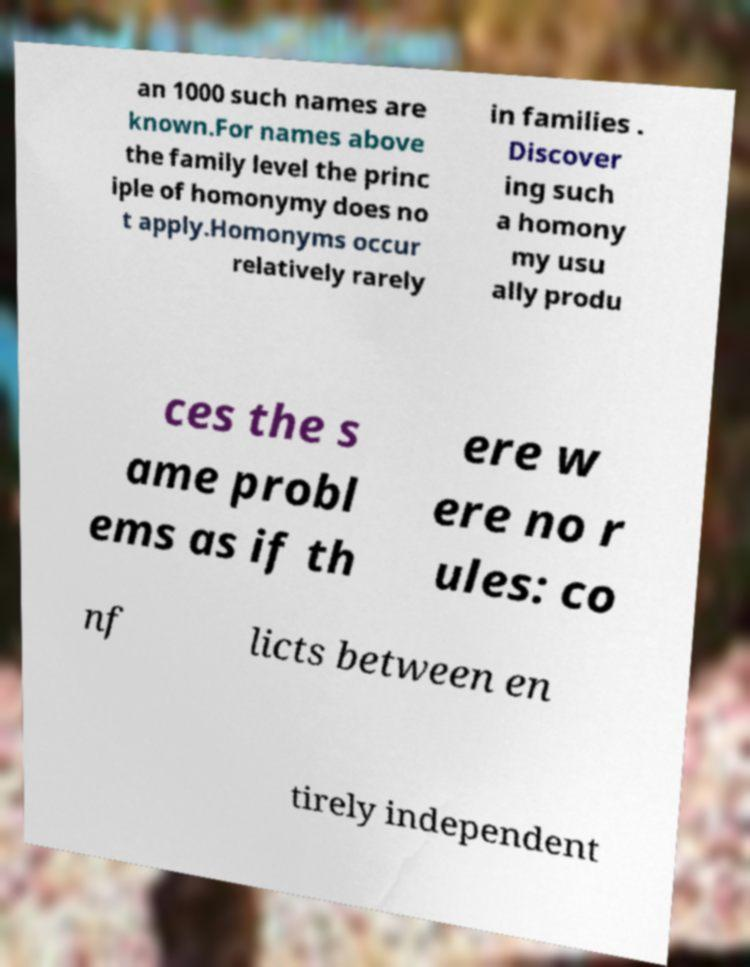Could you extract and type out the text from this image? an 1000 such names are known.For names above the family level the princ iple of homonymy does no t apply.Homonyms occur relatively rarely in families . Discover ing such a homony my usu ally produ ces the s ame probl ems as if th ere w ere no r ules: co nf licts between en tirely independent 